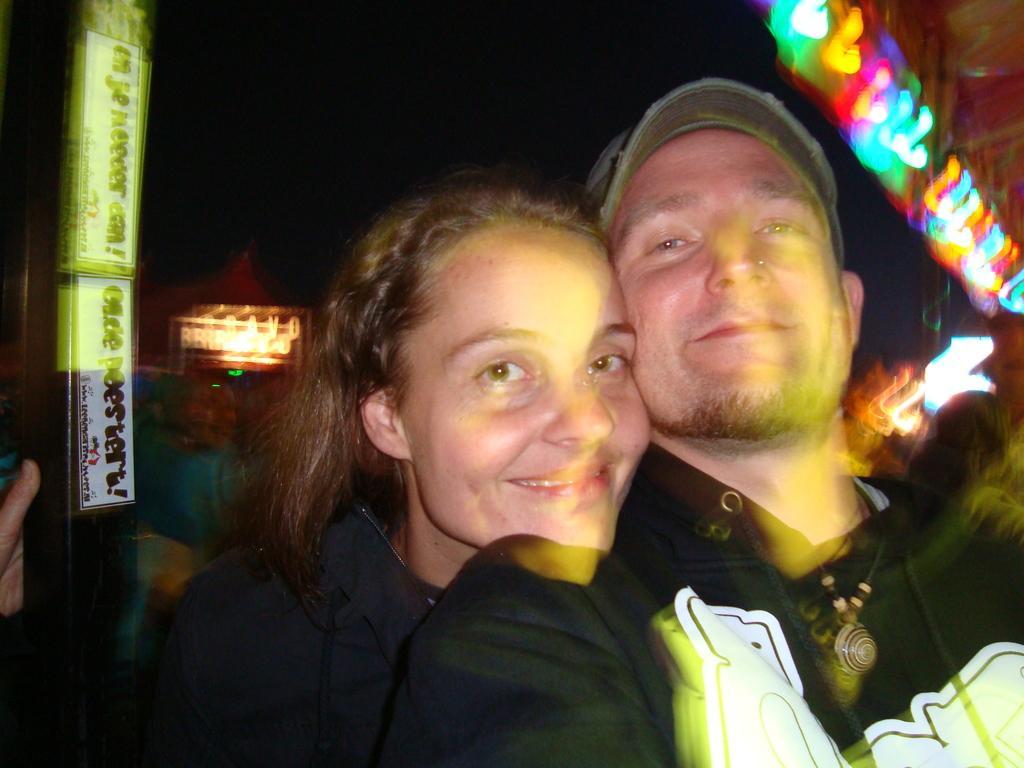Describe this image in one or two sentences. Front these two people are smiling and looking forward. Background there are lights and board. 